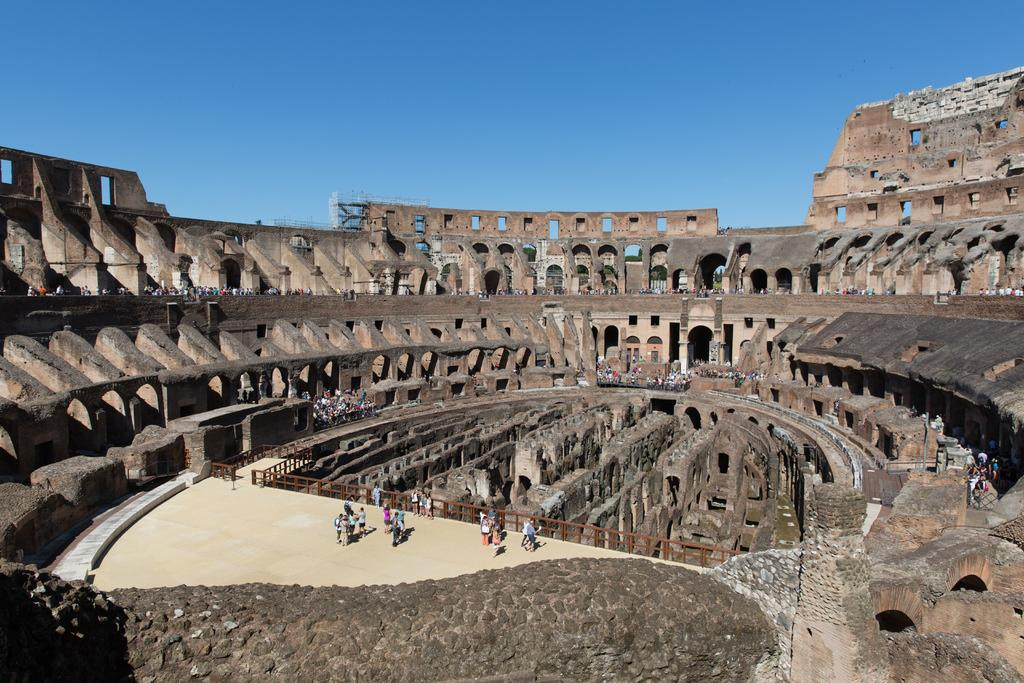What type of structure is present in the image? There is a building in the image. Are there any people inside the building? Yes, there are persons in the building. What part of the building can be seen in the image? There is a floor visible in the image. What type of barrier is present in the image? There is a fence in the image. What material is present in the image? There is a marble stone in the image. What is visible at the top of the image? The sky is visible at the top of the image. What type of bottle is being used to sing songs in the image? There is no bottle or singing in the image; it only features a building, persons, floor, fence, marble stone, and sky. 